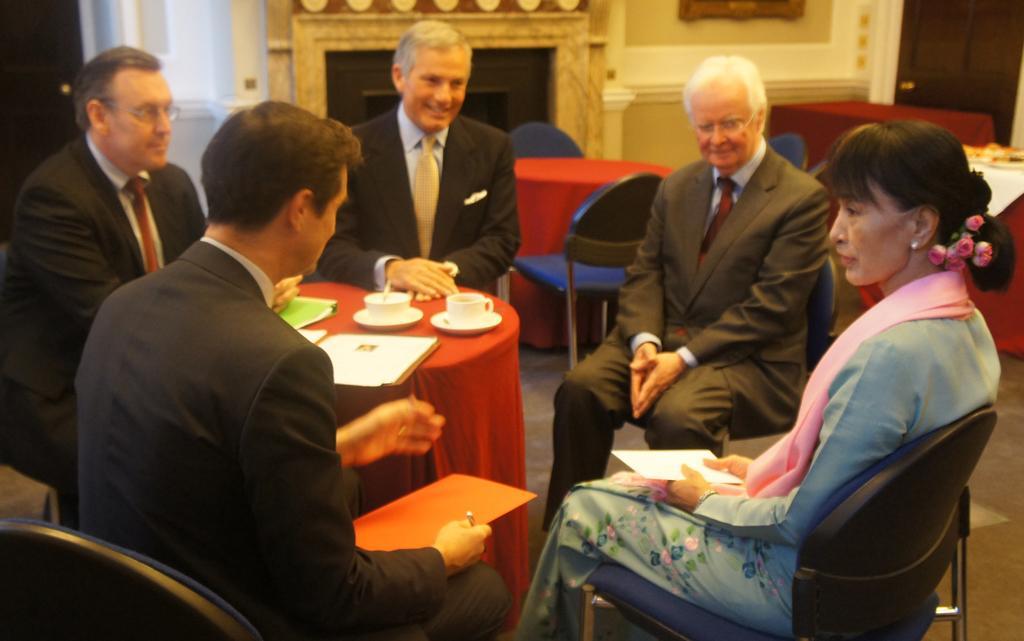In one or two sentences, can you explain what this image depicts? In this picture we can see people sitting on chairs near to a table and on the table we can see cups, saucers, papers and a file. In the background we can see chairs and tables. This is a floor. 